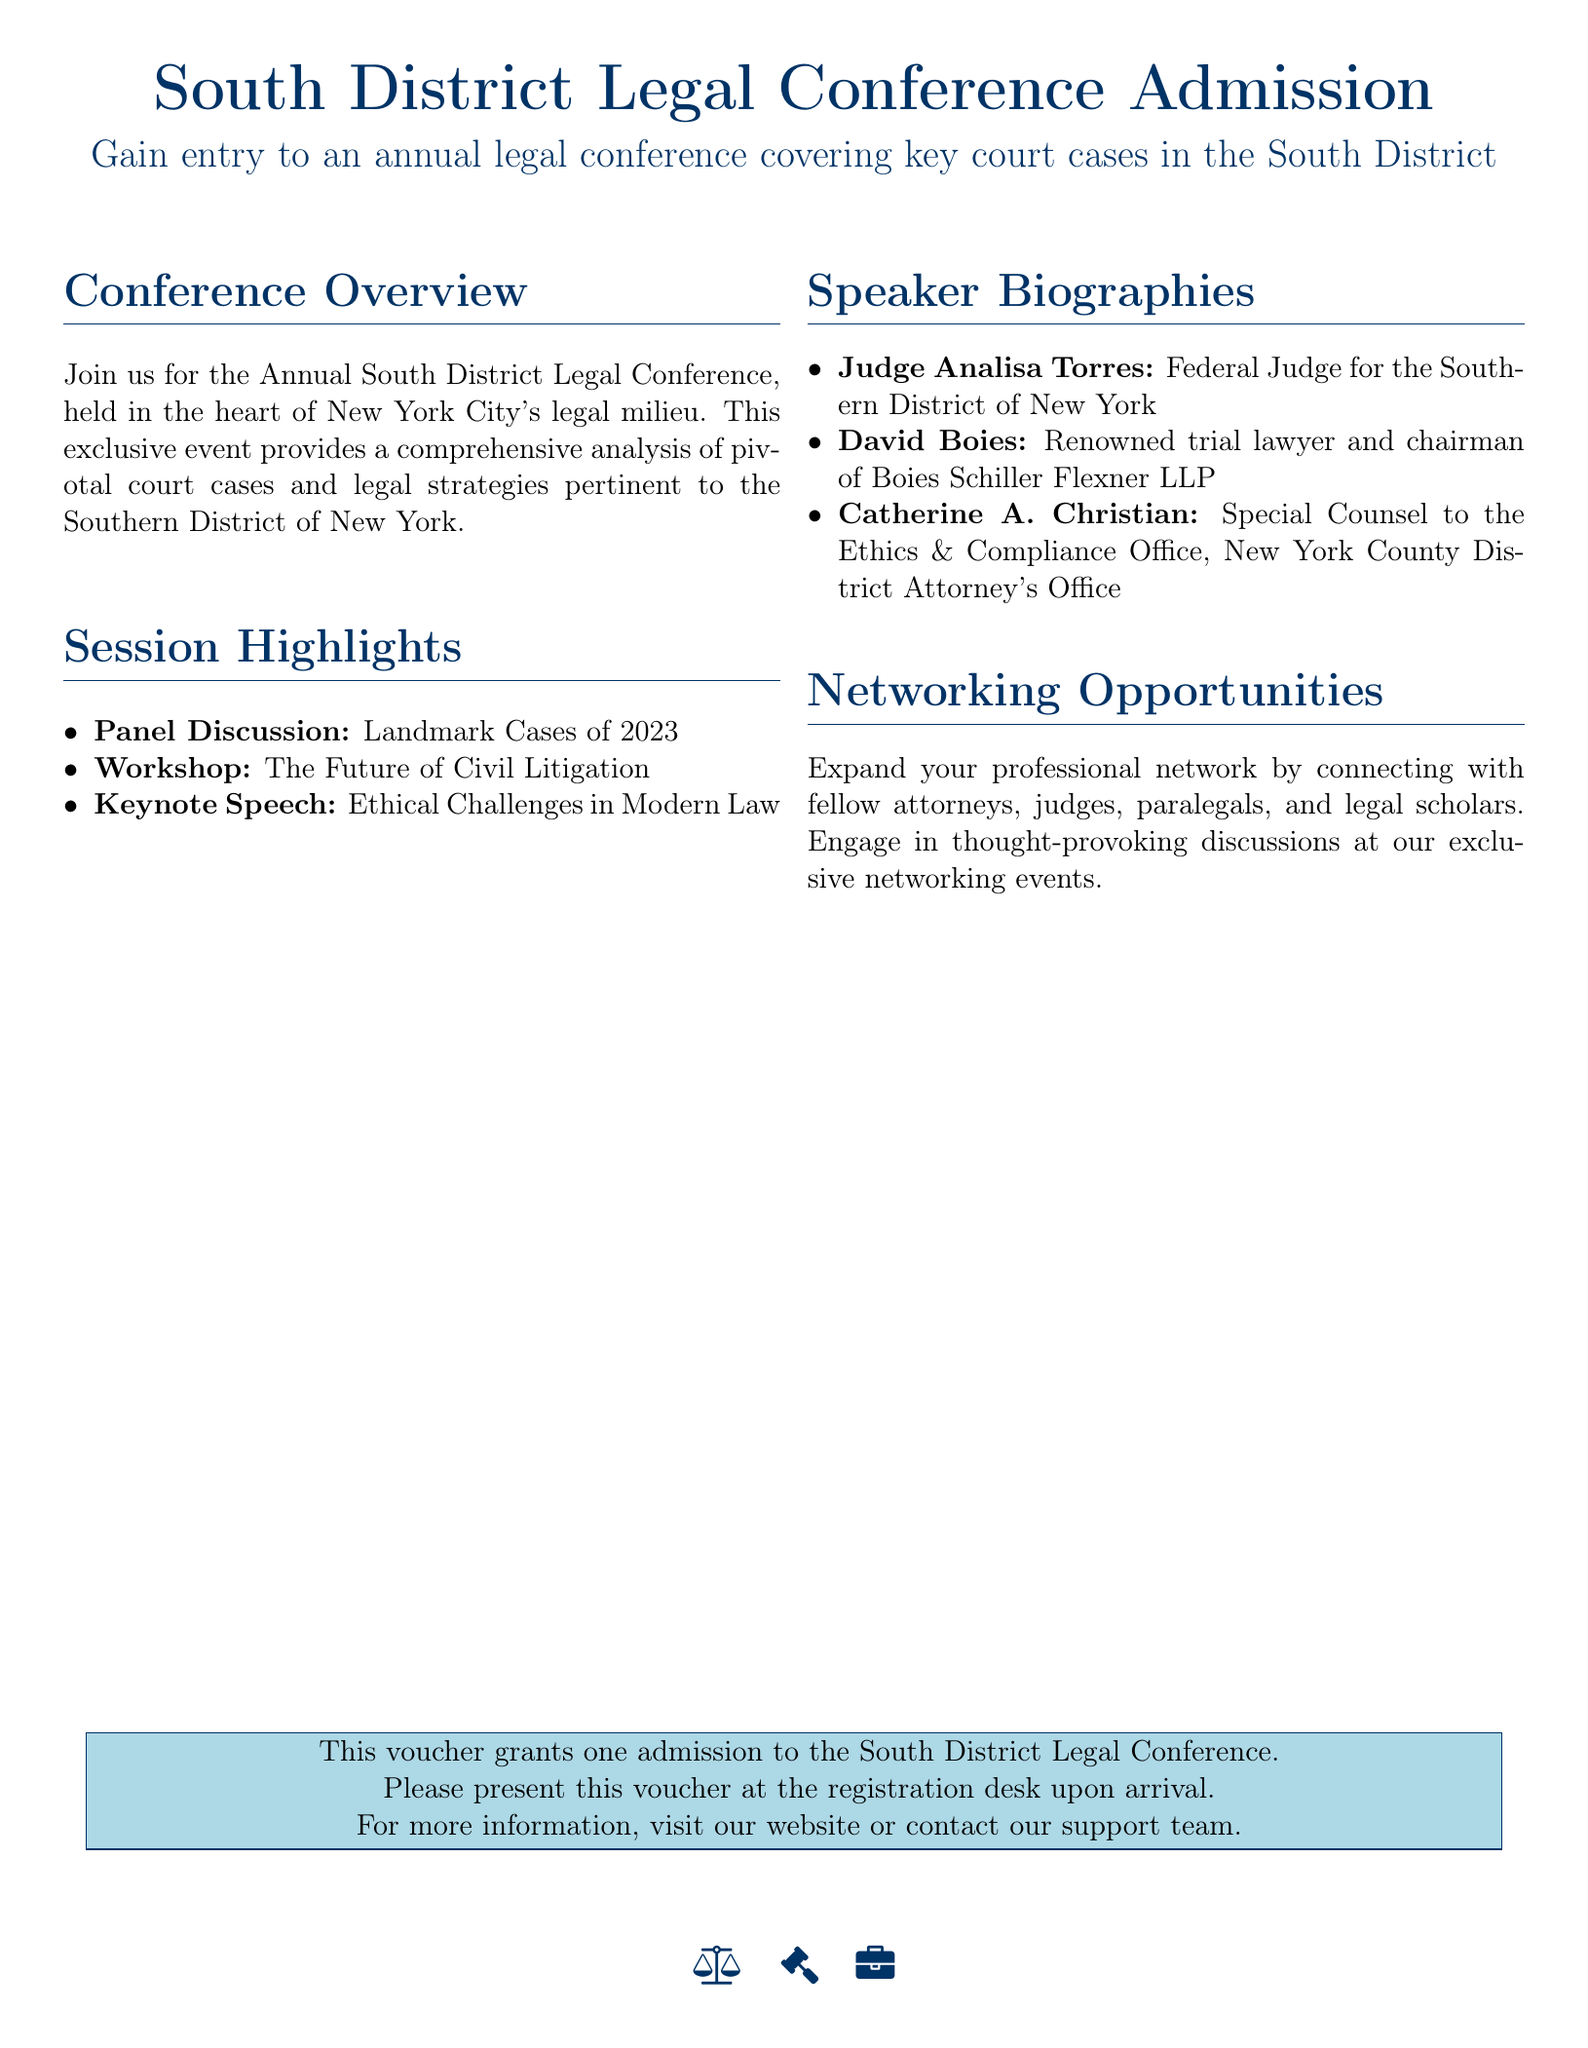What is the title of the conference? The title of the conference is mentioned in the document, which is "South District Legal Conference Admission."
Answer: South District Legal Conference Admission What is one of the session highlights? The document lists specific sessions under "Session Highlights," one of which is "Panel Discussion: Landmark Cases of 2023."
Answer: Panel Discussion: Landmark Cases of 2023 Who is the keynote speaker? The document specifies the keynote speech and its speaker under "Session Highlights." The keynote speaker is "Ethical Challenges in Modern Law."
Answer: Ethical Challenges in Modern Law What is the name of a speaker? The document provides information on various speakers under "Speaker Biographies," including "Judge Analisa Torres."
Answer: Judge Analisa Torres What type of certificate is this document? The document describes the purpose and nature of the voucher it represents, which grants admission to a specific event.
Answer: Gift voucher How can one use this voucher? The document states how to utilize the voucher for entry, specifically by presenting it at a certain location.
Answer: Present at the registration desk What opportunities are mentioned in the document? Under "Networking Opportunities," the document describes how attendees can expand their professional contacts.
Answer: Networking opportunities Where is the conference held? The document indicates that the conference takes place in a specific area, "the heart of New York City's legal milieu."
Answer: New York City What is included in the breakdown of sessions? The document outlines different types of events, including panel discussions and workshops, included in the session breakdown.
Answer: Panel Discussion, Workshop, Keynote Speech 